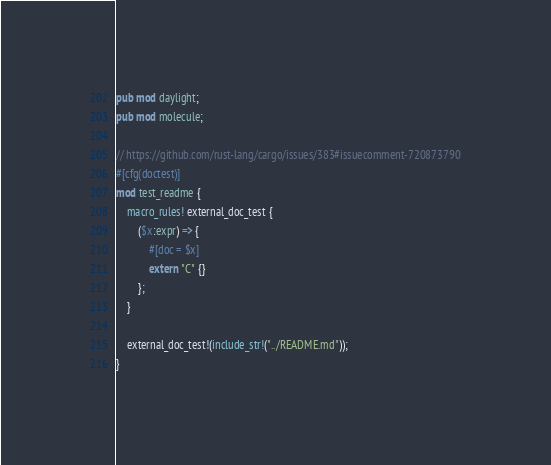<code> <loc_0><loc_0><loc_500><loc_500><_Rust_>pub mod daylight;
pub mod molecule;

// https://github.com/rust-lang/cargo/issues/383#issuecomment-720873790
#[cfg(doctest)]
mod test_readme {
    macro_rules! external_doc_test {
        ($x:expr) => {
            #[doc = $x]
            extern "C" {}
        };
    }

    external_doc_test!(include_str!("../README.md"));
}
</code> 